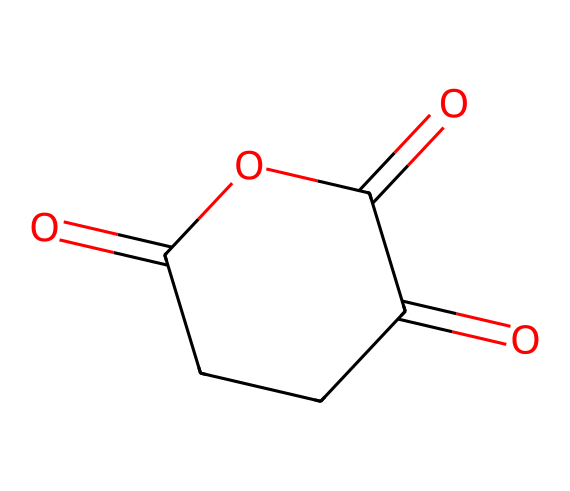How many carbon atoms are present in glutaric anhydride? The SMILES representation, O=C1CCC(=O)OC1=O, indicates a cyclic structure with a total of 5 carbon atoms visualized as 'C' in the formula.
Answer: five What is the central functional group in glutaric anhydride? Analyzing the SMILES, one can identify the anhydride functional group represented by the connections of carbonyl (C=O) to the ether-like oxygens (O).
Answer: anhydride How many double bonds are present in glutaric anhydride? The SMILES shows two occurrences of C=O, indicating two carbonyl functional groups, which are double bonds, amounting to a total of 2 double bonds.
Answer: two What type of acid is glutaric anhydride derived from? Glutaric anhydride is derived from glutaric acid, which can be inferred from its name and its structure that reflects the loss of water between carboxylic acid groups.
Answer: glutaric acid What is the degree of saturation in glutaric anhydride? The presence of carbon-carbon single bonds, along with two double bonds (C=O), indicates no rings or additional unsaturation beyond what is indicated, leading to a saturated structure.
Answer: saturated How many oxygen atoms are in the structure of glutaric anhydride? Examining the SMILES, O=C1CCC(=O)OC1=O shows there are three 'O' symbols, indicating three oxygen atoms in the compound.
Answer: three 